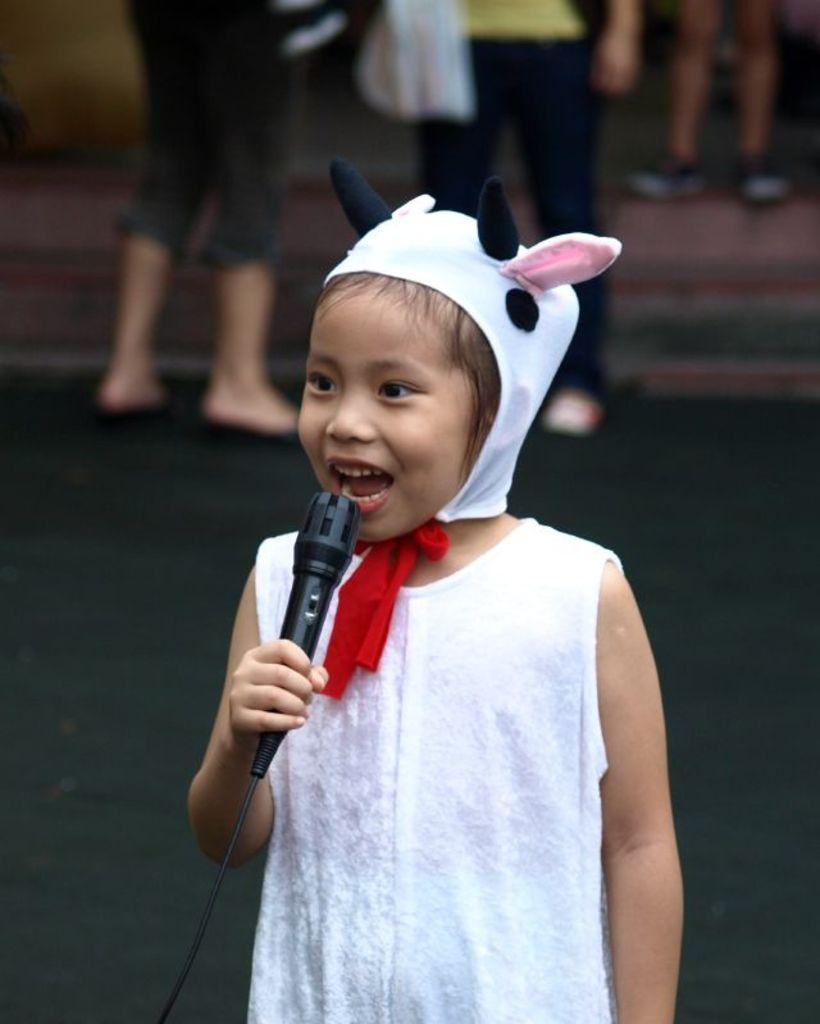Who is the main subject in the image? There is a girl in the image. What is the girl doing in the image? The girl is singing. What object is the girl holding in her hand? The girl is holding a microphone in her hand. Can you describe the background of the image? There are people standing in the background of the image. How many icicles are hanging from the girl's hair in the image? There are no icicles present in the image. What type of badge is the girl wearing in the image? The girl is not wearing a badge in the image. 